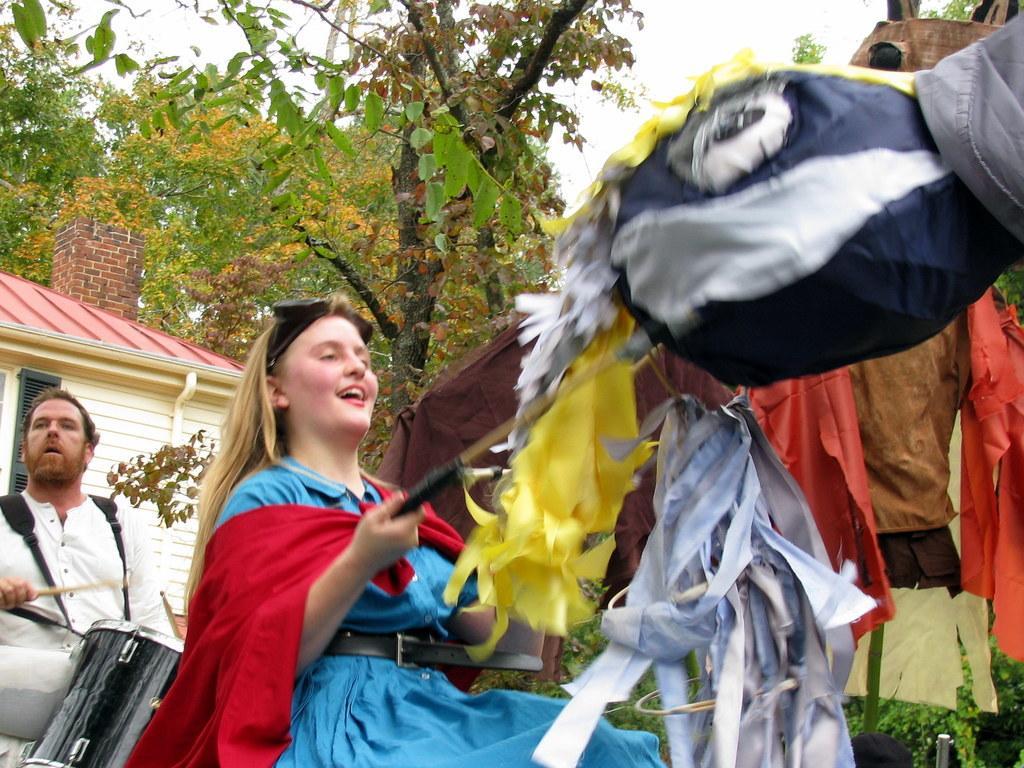Can you describe this image briefly? In the image we can see a woman wearing clothes and the woman is holding an object in her hand, behind her there is a man, holding a stick in his hand and this is a musical instrument. There is a building, trees and a sky, these are the clothes. 